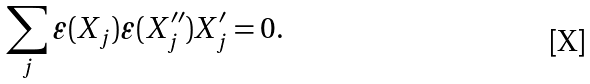Convert formula to latex. <formula><loc_0><loc_0><loc_500><loc_500>\sum _ { j } \varepsilon ( X _ { j } ) \varepsilon ( X ^ { \prime \prime } _ { j } ) X ^ { \prime } _ { j } = 0 .</formula> 